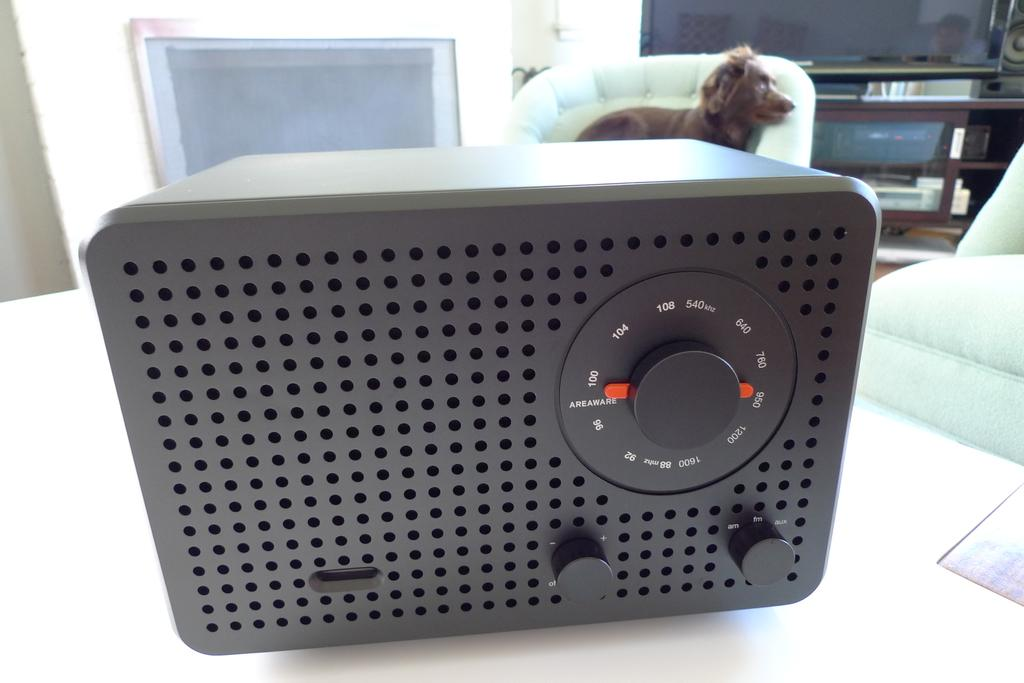What is the main subject on the platform in the image? There is a device on a platform in the image. Can you describe anything in the background of the image? Yes, there is a dog and other objects in the background of the image. How does the device connect to the bomb in the image? There is no bomb present in the image, so it cannot be connected to the device. 